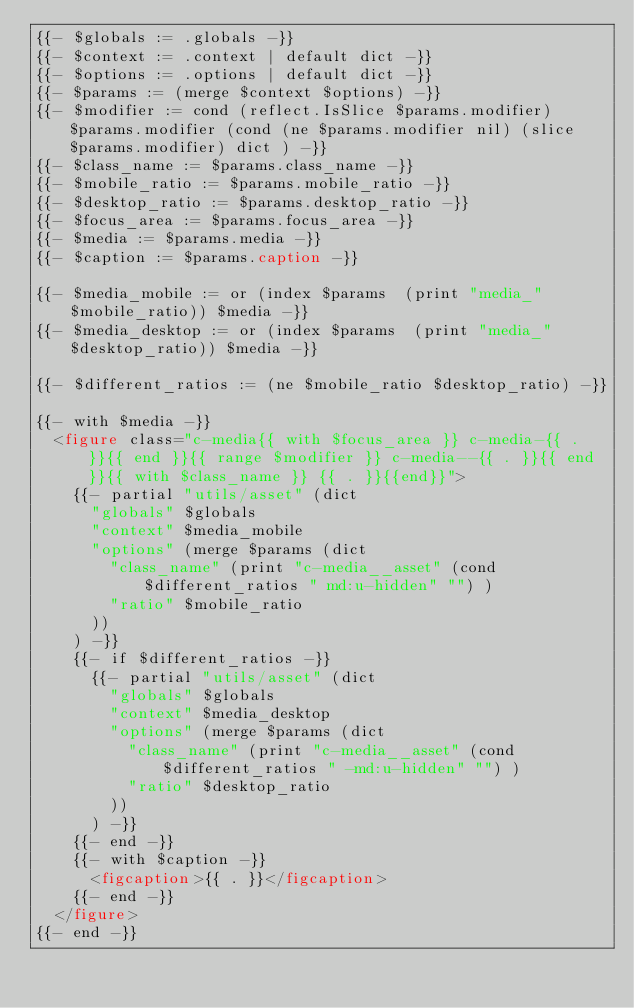Convert code to text. <code><loc_0><loc_0><loc_500><loc_500><_HTML_>{{- $globals := .globals -}}
{{- $context := .context | default dict -}}
{{- $options := .options | default dict -}}
{{- $params := (merge $context $options) -}}
{{- $modifier := cond (reflect.IsSlice $params.modifier) $params.modifier (cond (ne $params.modifier nil) (slice $params.modifier) dict ) -}}
{{- $class_name := $params.class_name -}}
{{- $mobile_ratio := $params.mobile_ratio -}}
{{- $desktop_ratio := $params.desktop_ratio -}}
{{- $focus_area := $params.focus_area -}}
{{- $media := $params.media -}}
{{- $caption := $params.caption -}}

{{- $media_mobile := or (index $params  (print "media_" $mobile_ratio)) $media -}}
{{- $media_desktop := or (index $params  (print "media_" $desktop_ratio)) $media -}}

{{- $different_ratios := (ne $mobile_ratio $desktop_ratio) -}}

{{- with $media -}}
  <figure class="c-media{{ with $focus_area }} c-media-{{ . }}{{ end }}{{ range $modifier }} c-media--{{ . }}{{ end }}{{ with $class_name }} {{ . }}{{end}}">
    {{- partial "utils/asset" (dict
      "globals" $globals
      "context" $media_mobile
      "options" (merge $params (dict
        "class_name" (print "c-media__asset" (cond $different_ratios " md:u-hidden" "") )
        "ratio" $mobile_ratio
      ))
    ) -}}
    {{- if $different_ratios -}}
      {{- partial "utils/asset" (dict
        "globals" $globals
        "context" $media_desktop
        "options" (merge $params (dict
          "class_name" (print "c-media__asset" (cond $different_ratios " -md:u-hidden" "") )
          "ratio" $desktop_ratio
        ))
      ) -}}
    {{- end -}}
    {{- with $caption -}}
      <figcaption>{{ . }}</figcaption>
    {{- end -}}
  </figure>
{{- end -}}
</code> 